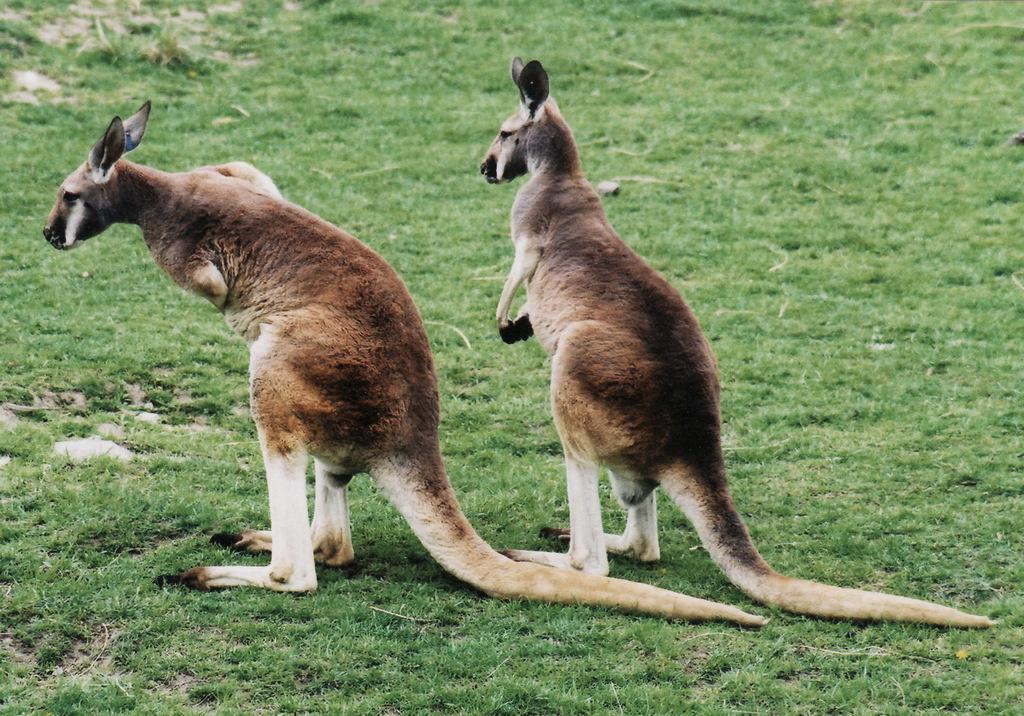What animals are present in the image? There are two kangaroos in the image. What is the kangaroos' location in the image? The kangaroos are standing on the grass. What type of rose is the kangaroo holding in the image? There is no rose present in the image; the kangaroos are not holding anything. 